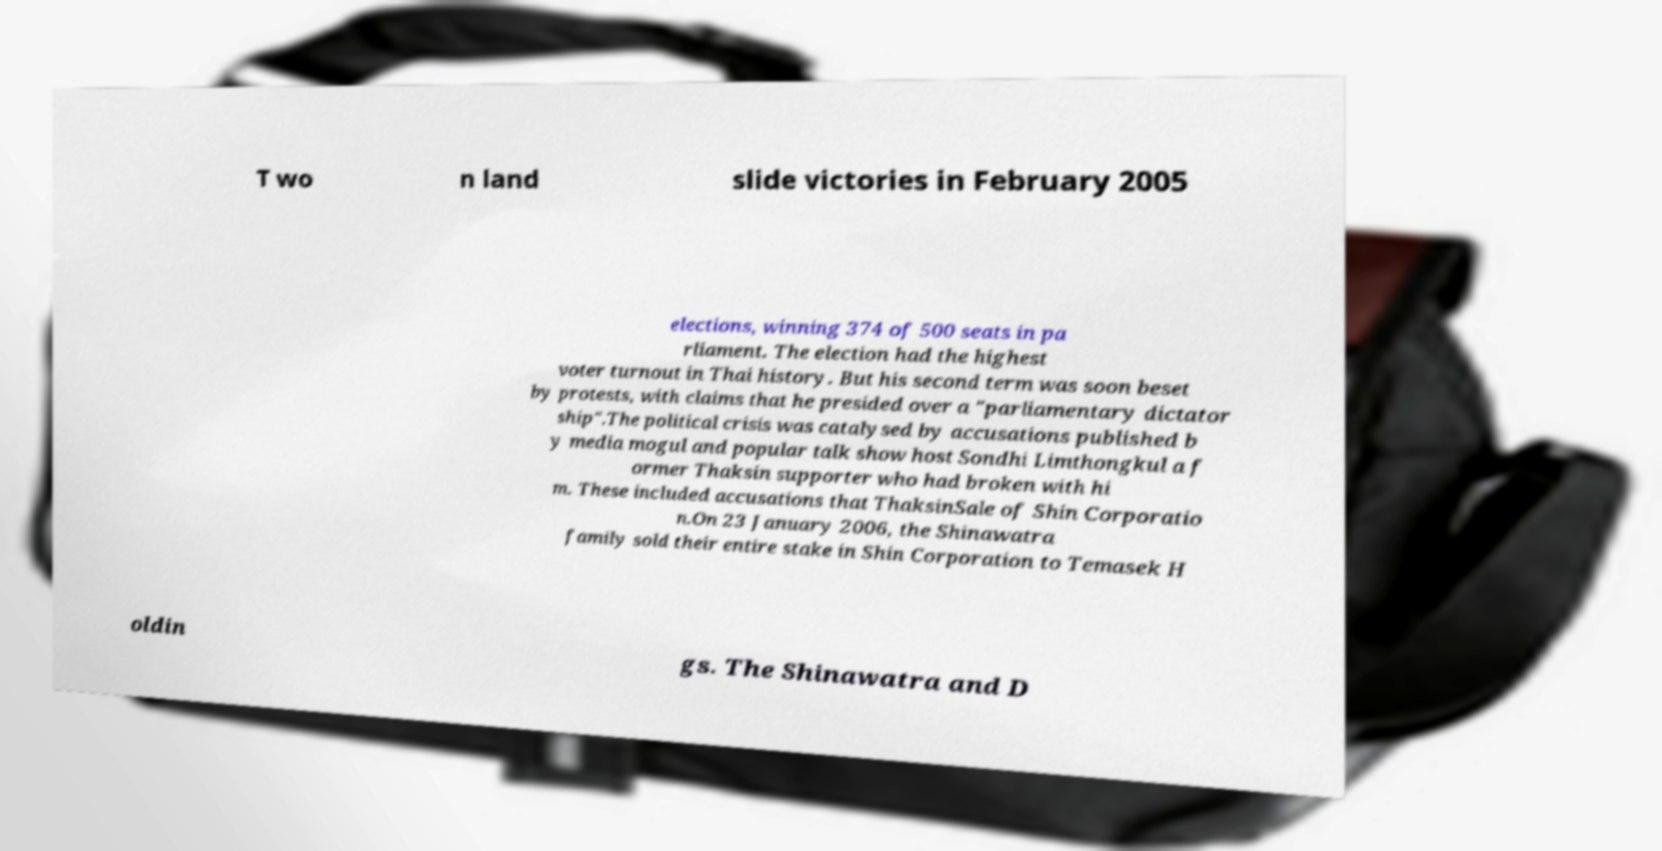There's text embedded in this image that I need extracted. Can you transcribe it verbatim? T wo n land slide victories in February 2005 elections, winning 374 of 500 seats in pa rliament. The election had the highest voter turnout in Thai history. But his second term was soon beset by protests, with claims that he presided over a "parliamentary dictator ship".The political crisis was catalysed by accusations published b y media mogul and popular talk show host Sondhi Limthongkul a f ormer Thaksin supporter who had broken with hi m. These included accusations that ThaksinSale of Shin Corporatio n.On 23 January 2006, the Shinawatra family sold their entire stake in Shin Corporation to Temasek H oldin gs. The Shinawatra and D 